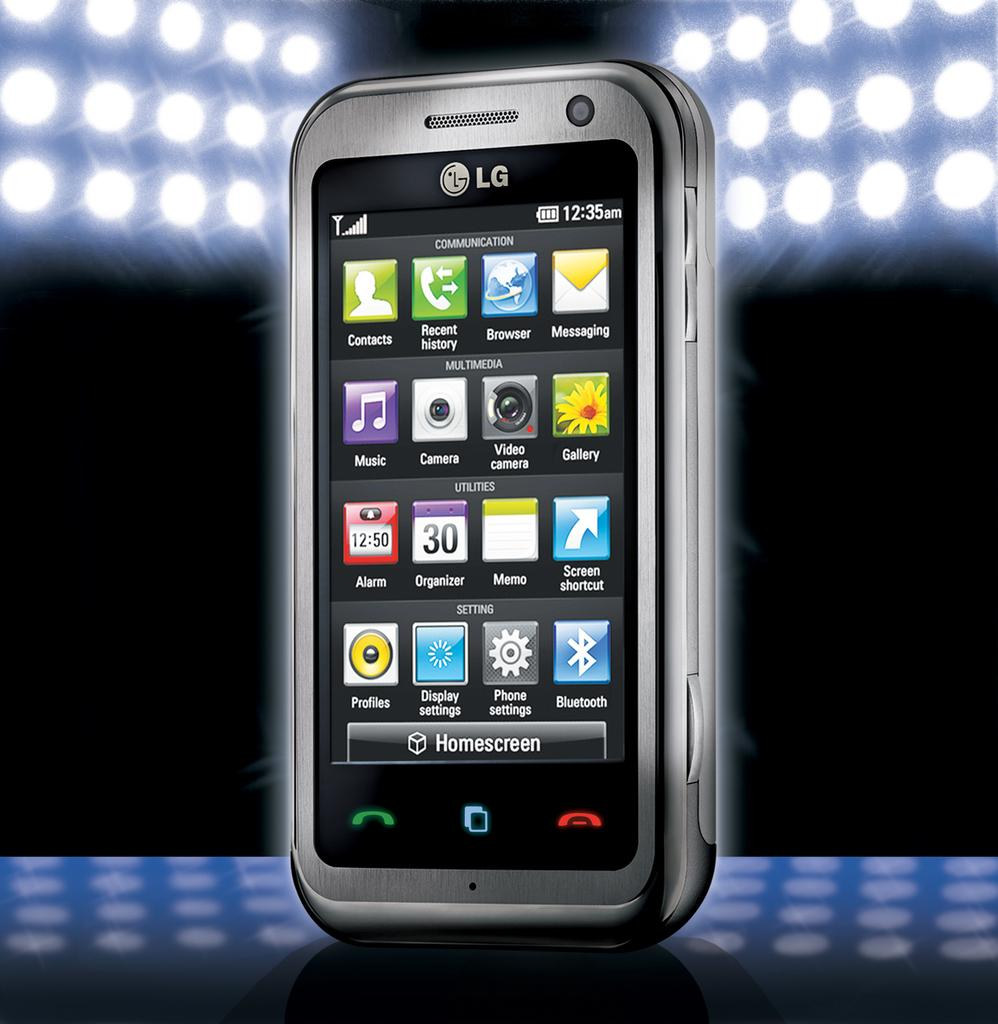<image>
Describe the image concisely. An LG phone with various icons displayed like Camera, Organizer, and Bluetooth 